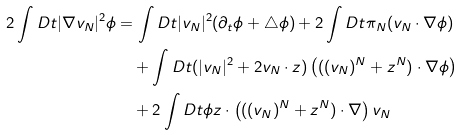<formula> <loc_0><loc_0><loc_500><loc_500>2 \int D t | \nabla v _ { N } | ^ { 2 } \phi & = \int D t | v _ { N } | ^ { 2 } ( \partial _ { t } \phi + \triangle \phi ) + 2 \int D t \pi _ { N } ( v _ { N } \cdot \nabla \phi ) \\ & \quad + \int D t ( | v _ { N } | ^ { 2 } + 2 v _ { N } \cdot z ) \left ( ( ( v _ { N } ) ^ { N } + z ^ { N } ) \cdot \nabla \phi \right ) \\ & \quad + 2 \int D t \phi z \cdot \left ( ( ( v _ { N } ) ^ { N } + z ^ { N } ) \cdot \nabla \right ) v _ { N }</formula> 